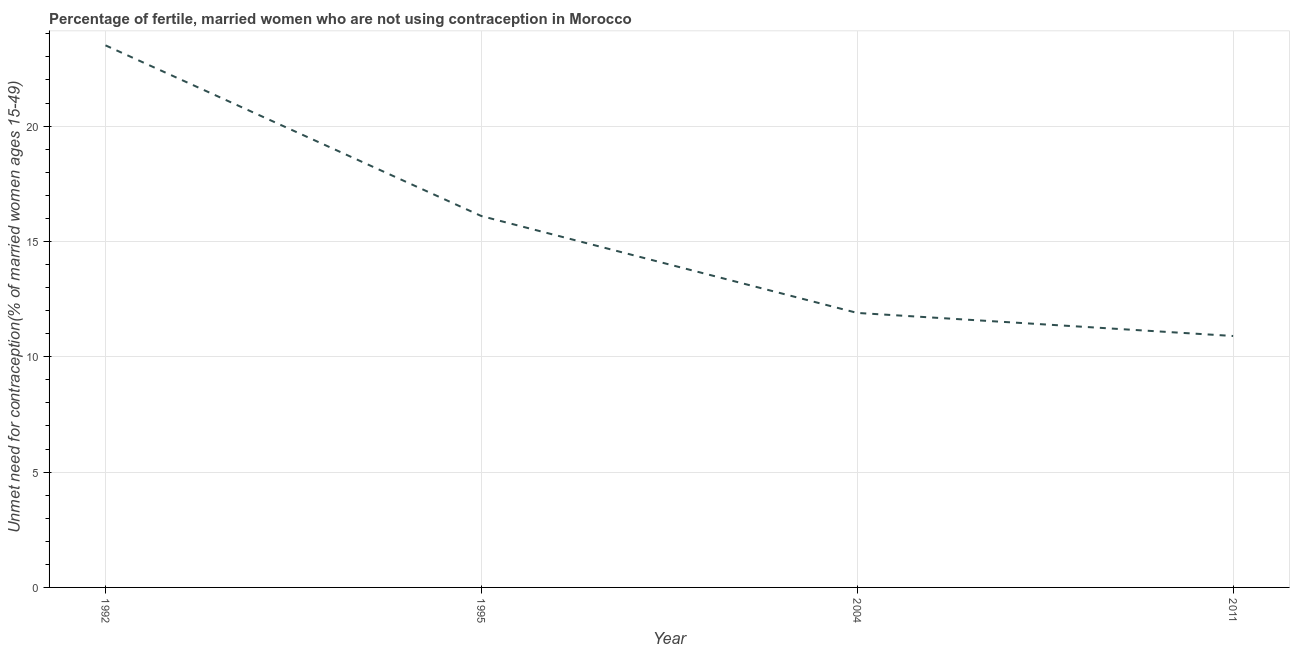Across all years, what is the maximum number of married women who are not using contraception?
Provide a short and direct response. 23.5. In which year was the number of married women who are not using contraception minimum?
Provide a succinct answer. 2011. What is the sum of the number of married women who are not using contraception?
Your response must be concise. 62.4. What is the difference between the number of married women who are not using contraception in 1992 and 2011?
Your answer should be very brief. 12.6. In how many years, is the number of married women who are not using contraception greater than 12 %?
Provide a short and direct response. 2. Do a majority of the years between 2004 and 2011 (inclusive) have number of married women who are not using contraception greater than 13 %?
Keep it short and to the point. No. What is the ratio of the number of married women who are not using contraception in 1992 to that in 1995?
Offer a very short reply. 1.46. Is the number of married women who are not using contraception in 1992 less than that in 2004?
Provide a short and direct response. No. Is the difference between the number of married women who are not using contraception in 2004 and 2011 greater than the difference between any two years?
Keep it short and to the point. No. What is the difference between the highest and the second highest number of married women who are not using contraception?
Provide a short and direct response. 7.4. Is the sum of the number of married women who are not using contraception in 1995 and 2011 greater than the maximum number of married women who are not using contraception across all years?
Make the answer very short. Yes. In how many years, is the number of married women who are not using contraception greater than the average number of married women who are not using contraception taken over all years?
Offer a terse response. 2. Does the number of married women who are not using contraception monotonically increase over the years?
Keep it short and to the point. No. How many years are there in the graph?
Your answer should be compact. 4. Does the graph contain grids?
Provide a short and direct response. Yes. What is the title of the graph?
Keep it short and to the point. Percentage of fertile, married women who are not using contraception in Morocco. What is the label or title of the X-axis?
Make the answer very short. Year. What is the label or title of the Y-axis?
Make the answer very short.  Unmet need for contraception(% of married women ages 15-49). What is the  Unmet need for contraception(% of married women ages 15-49) in 1995?
Your answer should be compact. 16.1. What is the difference between the  Unmet need for contraception(% of married women ages 15-49) in 1992 and 2004?
Make the answer very short. 11.6. What is the difference between the  Unmet need for contraception(% of married women ages 15-49) in 1995 and 2011?
Keep it short and to the point. 5.2. What is the difference between the  Unmet need for contraception(% of married women ages 15-49) in 2004 and 2011?
Make the answer very short. 1. What is the ratio of the  Unmet need for contraception(% of married women ages 15-49) in 1992 to that in 1995?
Ensure brevity in your answer.  1.46. What is the ratio of the  Unmet need for contraception(% of married women ages 15-49) in 1992 to that in 2004?
Ensure brevity in your answer.  1.98. What is the ratio of the  Unmet need for contraception(% of married women ages 15-49) in 1992 to that in 2011?
Keep it short and to the point. 2.16. What is the ratio of the  Unmet need for contraception(% of married women ages 15-49) in 1995 to that in 2004?
Your answer should be compact. 1.35. What is the ratio of the  Unmet need for contraception(% of married women ages 15-49) in 1995 to that in 2011?
Provide a succinct answer. 1.48. What is the ratio of the  Unmet need for contraception(% of married women ages 15-49) in 2004 to that in 2011?
Ensure brevity in your answer.  1.09. 